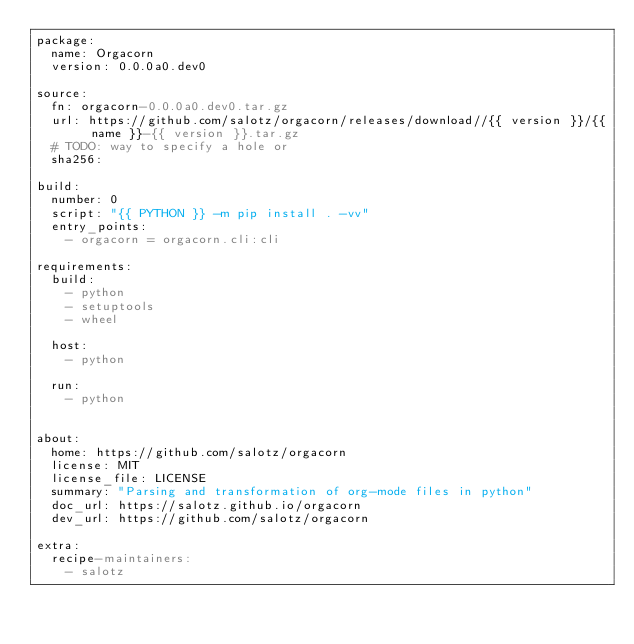<code> <loc_0><loc_0><loc_500><loc_500><_YAML_>package:
  name: Orgacorn
  version: 0.0.0a0.dev0

source:
  fn: orgacorn-0.0.0a0.dev0.tar.gz
  url: https://github.com/salotz/orgacorn/releases/download//{{ version }}/{{ name }}-{{ version }}.tar.gz
  # TODO: way to specify a hole or 
  sha256:

build:
  number: 0
  script: "{{ PYTHON }} -m pip install . -vv"
  entry_points:
    - orgacorn = orgacorn.cli:cli

requirements:
  build:
    - python
    - setuptools
    - wheel

  host:
    - python
    
  run:
    - python
    

about:
  home: https://github.com/salotz/orgacorn
  license: MIT
  license_file: LICENSE
  summary: "Parsing and transformation of org-mode files in python"
  doc_url: https://salotz.github.io/orgacorn
  dev_url: https://github.com/salotz/orgacorn

extra:
  recipe-maintainers:
    - salotz
</code> 